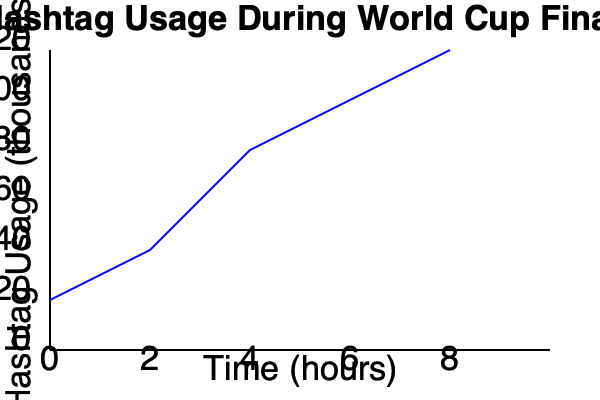Based on the line graph showing hashtag usage during the World Cup Final, what was the approximate rate of increase in hashtag usage (in thousands per hour) between the 2-hour and 6-hour marks of the event? To calculate the rate of increase in hashtag usage between the 2-hour and 6-hour marks, we need to follow these steps:

1. Identify the hashtag usage at the 2-hour mark: 
   At 2 hours, the usage is approximately 40,000 hashtags.

2. Identify the hashtag usage at the 6-hour mark:
   At 6 hours, the usage is approximately 100,000 hashtags.

3. Calculate the change in hashtag usage:
   Change in usage = 100,000 - 40,000 = 60,000 hashtags

4. Calculate the time interval:
   Time interval = 6 hours - 2 hours = 4 hours

5. Calculate the rate of increase:
   Rate = Change in usage / Time interval
   Rate = 60,000 / 4 = 15,000 hashtags per hour

Therefore, the approximate rate of increase in hashtag usage between the 2-hour and 6-hour marks was 15,000 hashtags per hour, or 15 thousand per hour.
Answer: 15 thousand per hour 